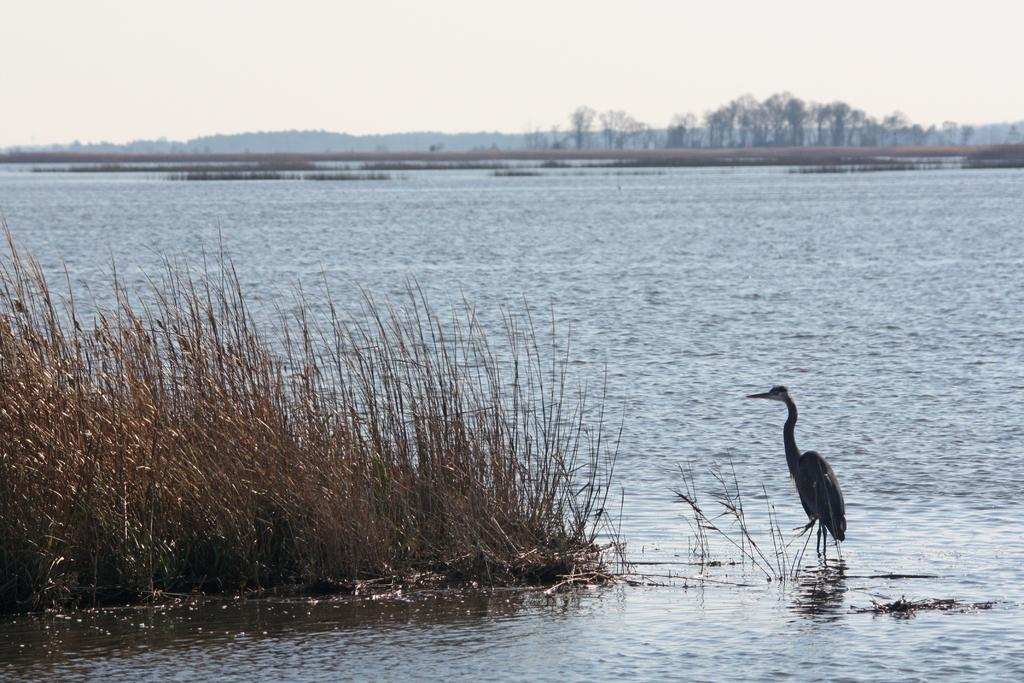What type of animal can be seen in the water in the image? There is a bird in the water in the image. What other natural elements are present in the image? There are plants, trees, and mountains visible in the image. What part of the natural environment is visible in the background of the image? The sky is visible in the background of the image. What shape is the roof of the bird in the image? There is no roof present in the image, as it features a bird in the water and birds do not have roofs. 